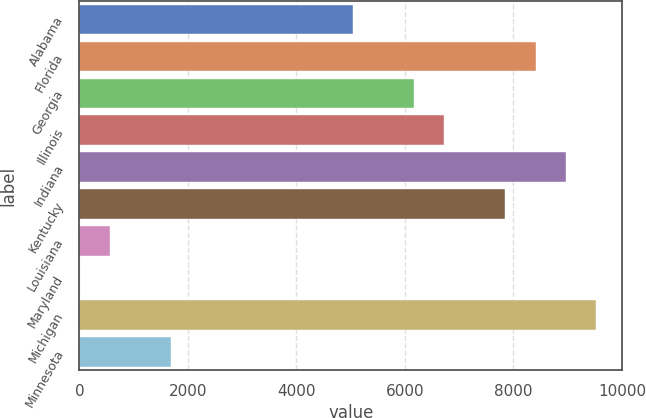Convert chart. <chart><loc_0><loc_0><loc_500><loc_500><bar_chart><fcel>Alabama<fcel>Florida<fcel>Georgia<fcel>Illinois<fcel>Indiana<fcel>Kentucky<fcel>Louisiana<fcel>Maryland<fcel>Michigan<fcel>Minnesota<nl><fcel>5046.4<fcel>8410<fcel>6167.6<fcel>6728.2<fcel>8970.6<fcel>7849.4<fcel>561.6<fcel>1<fcel>9531.2<fcel>1682.8<nl></chart> 